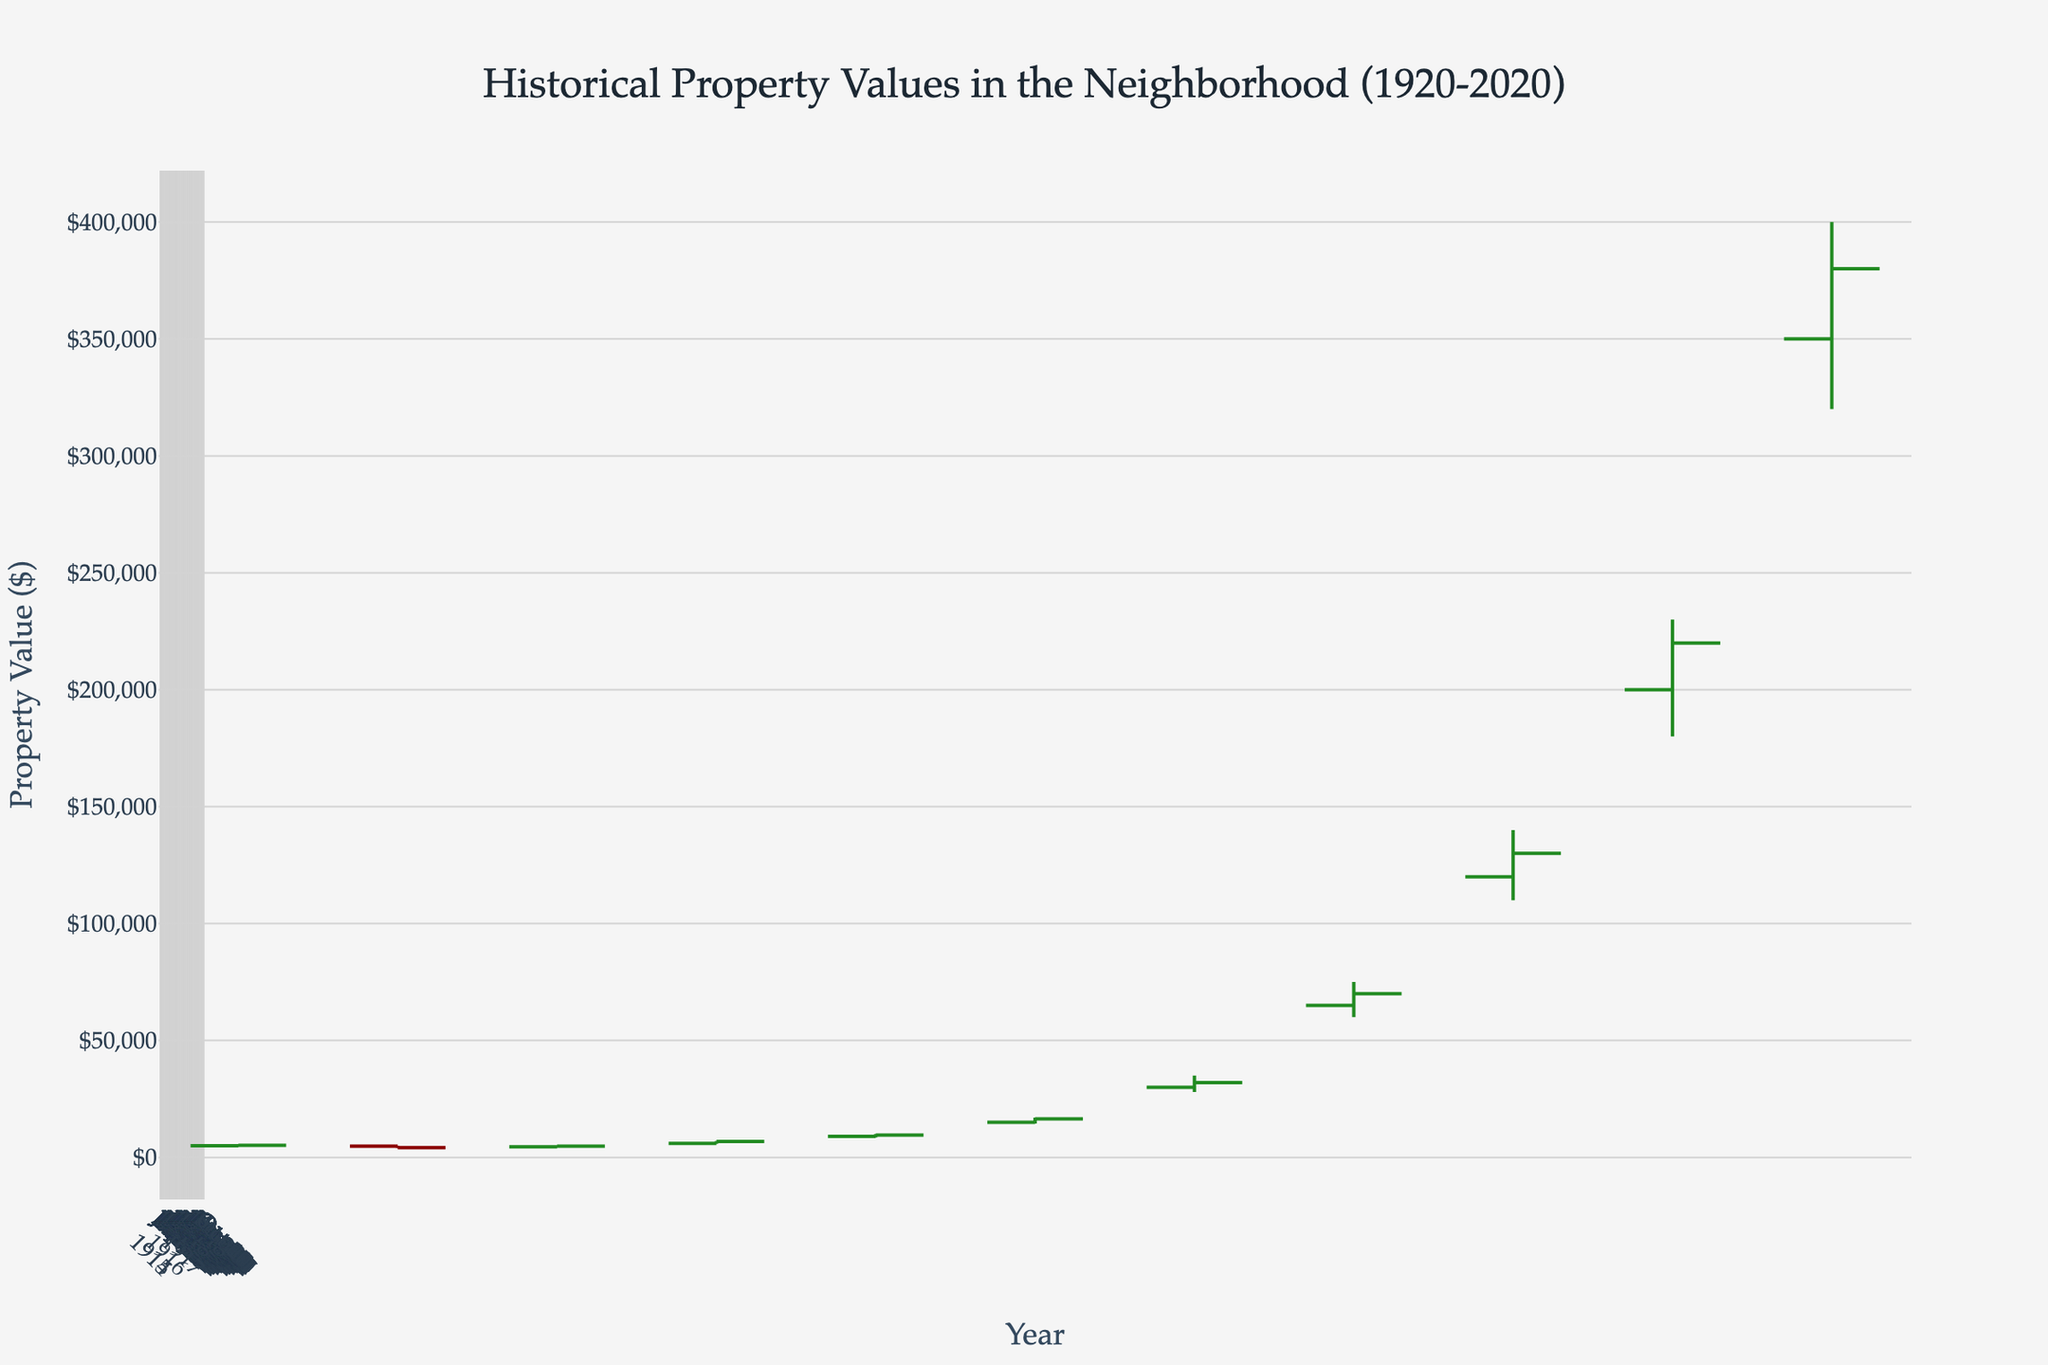What is the title of the figure? The title of the figure is displayed at the top, in larger font, and it reads 'Historical Property Values in the Neighborhood (1920-2020)'.
Answer: Historical Property Values in the Neighborhood (1920-2020) What is the highest property value recorded on the chart? The highest property value recorded on the chart is seen at the peak of the "High" column for the year 2020, showing a value of $400,000.
Answer: $400,000 How many data points are shown on the x-axis? The x-axis has data points representing each decade from 1920 to 2020. Counting these, there are 11 data points.
Answer: 11 Which year showed the lowest closing property value? By examining the "Close" values for each year, the lowest closing property value is in 1930, recorded at $4,200.
Answer: 1930 What is the range of the property value in 1980? The range is the difference between the highest and lowest property values for that year. For 1980, it is $35,000 (High) - $28,000 (Low) = $7,000.
Answer: $7,000 Which year experienced the greatest increase in closing property value compared to the previous decade? By comparing the "Close" values for each decade, the year 1980 experienced the greatest increase in closing value from the previous decade, with the increase from $16,500 (1970) to $32,000 (1980).
Answer: 1980 Between 1940 and 1950, did property values increase or decrease? Referring to the "Close" values, property values increased from $4,800 in 1940 to $6,800 in 1950.
Answer: Increase What is the average closing property value across the decades shown? Add up all the closing values (5200, 4200, 4800, 6800, 9500, 16500, 32000, 70000, 130000, 220000, 380000) to get 793,000. Divide by the number of data points (11): 793,000 / 11 = 72,090.91.
Answer: 72,090.91 By how much did the highest property value increase from 1960 to 1970? The highest property value in 1960 was $10,000, and in 1970 it was $17,000. The increase is $17,000 - $10,000 = $7,000.
Answer: $7,000 What is the median closing property value over the entire period? List the closing values in ascending order: (4200, 4800, 5200, 6800, 9500, 16500, 32000, 70000, 130000, 220000, 380000). The middle value is the median, which is the 6th value: $16,500.
Answer: $16,500 